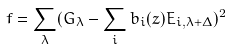<formula> <loc_0><loc_0><loc_500><loc_500>f = \sum _ { \lambda } ( G _ { \lambda } - \sum _ { i } b _ { i } ( z ) E _ { i , \lambda + \Delta } ) ^ { 2 }</formula> 